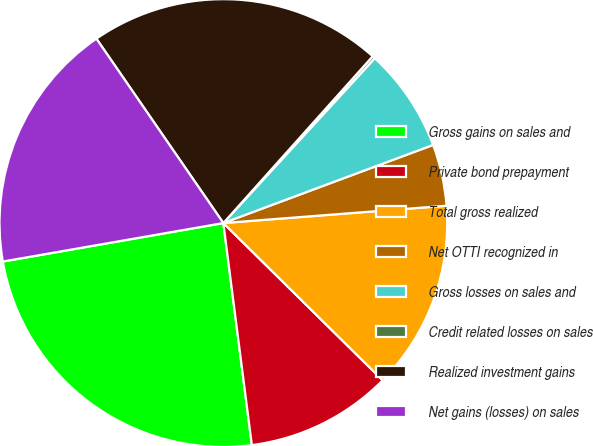<chart> <loc_0><loc_0><loc_500><loc_500><pie_chart><fcel>Gross gains on sales and<fcel>Private bond prepayment<fcel>Total gross realized<fcel>Net OTTI recognized in<fcel>Gross losses on sales and<fcel>Credit related losses on sales<fcel>Realized investment gains<fcel>Net gains (losses) on sales<nl><fcel>24.28%<fcel>10.57%<fcel>13.63%<fcel>4.44%<fcel>7.5%<fcel>0.2%<fcel>21.22%<fcel>18.15%<nl></chart> 